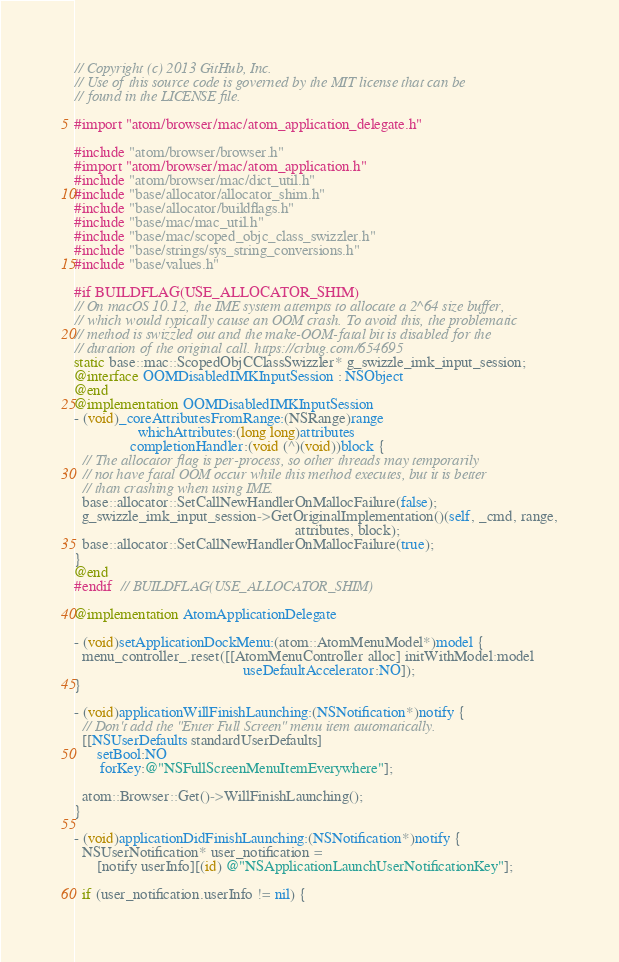<code> <loc_0><loc_0><loc_500><loc_500><_ObjectiveC_>// Copyright (c) 2013 GitHub, Inc.
// Use of this source code is governed by the MIT license that can be
// found in the LICENSE file.

#import "atom/browser/mac/atom_application_delegate.h"

#include "atom/browser/browser.h"
#import "atom/browser/mac/atom_application.h"
#include "atom/browser/mac/dict_util.h"
#include "base/allocator/allocator_shim.h"
#include "base/allocator/buildflags.h"
#include "base/mac/mac_util.h"
#include "base/mac/scoped_objc_class_swizzler.h"
#include "base/strings/sys_string_conversions.h"
#include "base/values.h"

#if BUILDFLAG(USE_ALLOCATOR_SHIM)
// On macOS 10.12, the IME system attempts to allocate a 2^64 size buffer,
// which would typically cause an OOM crash. To avoid this, the problematic
// method is swizzled out and the make-OOM-fatal bit is disabled for the
// duration of the original call. https://crbug.com/654695
static base::mac::ScopedObjCClassSwizzler* g_swizzle_imk_input_session;
@interface OOMDisabledIMKInputSession : NSObject
@end
@implementation OOMDisabledIMKInputSession
- (void)_coreAttributesFromRange:(NSRange)range
                 whichAttributes:(long long)attributes
               completionHandler:(void (^)(void))block {
  // The allocator flag is per-process, so other threads may temporarily
  // not have fatal OOM occur while this method executes, but it is better
  // than crashing when using IME.
  base::allocator::SetCallNewHandlerOnMallocFailure(false);
  g_swizzle_imk_input_session->GetOriginalImplementation()(self, _cmd, range,
                                                           attributes, block);
  base::allocator::SetCallNewHandlerOnMallocFailure(true);
}
@end
#endif  // BUILDFLAG(USE_ALLOCATOR_SHIM)

@implementation AtomApplicationDelegate

- (void)setApplicationDockMenu:(atom::AtomMenuModel*)model {
  menu_controller_.reset([[AtomMenuController alloc] initWithModel:model
                                             useDefaultAccelerator:NO]);
}

- (void)applicationWillFinishLaunching:(NSNotification*)notify {
  // Don't add the "Enter Full Screen" menu item automatically.
  [[NSUserDefaults standardUserDefaults]
      setBool:NO
       forKey:@"NSFullScreenMenuItemEverywhere"];

  atom::Browser::Get()->WillFinishLaunching();
}

- (void)applicationDidFinishLaunching:(NSNotification*)notify {
  NSUserNotification* user_notification =
      [notify userInfo][(id) @"NSApplicationLaunchUserNotificationKey"];

  if (user_notification.userInfo != nil) {</code> 